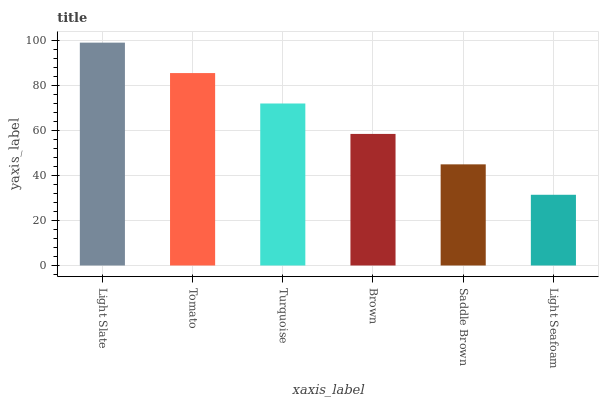Is Tomato the minimum?
Answer yes or no. No. Is Tomato the maximum?
Answer yes or no. No. Is Light Slate greater than Tomato?
Answer yes or no. Yes. Is Tomato less than Light Slate?
Answer yes or no. Yes. Is Tomato greater than Light Slate?
Answer yes or no. No. Is Light Slate less than Tomato?
Answer yes or no. No. Is Turquoise the high median?
Answer yes or no. Yes. Is Brown the low median?
Answer yes or no. Yes. Is Tomato the high median?
Answer yes or no. No. Is Light Slate the low median?
Answer yes or no. No. 